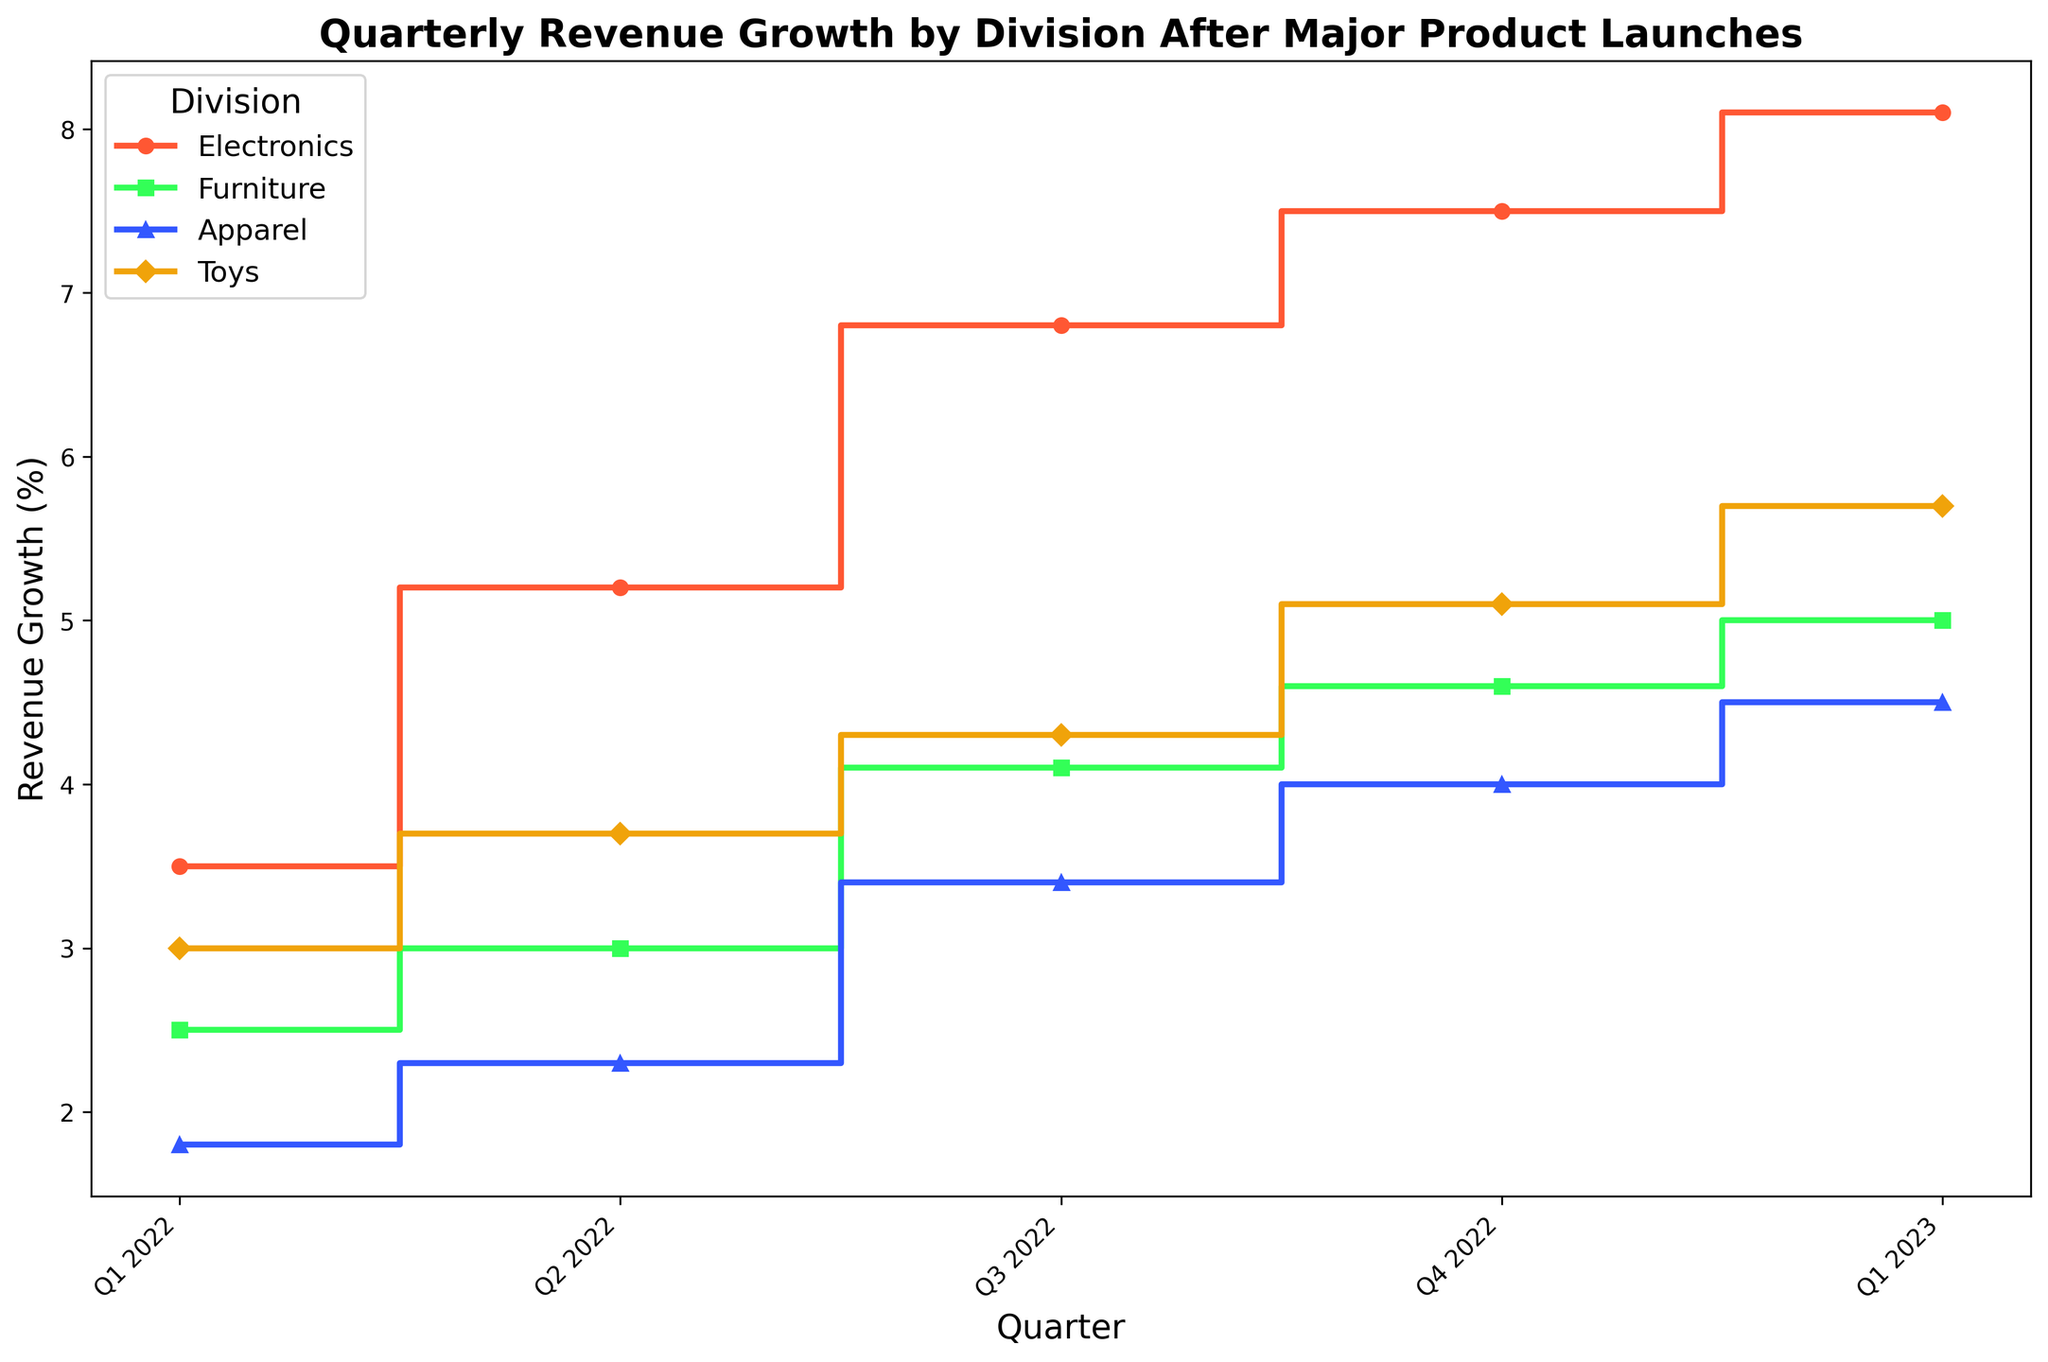Which division had the highest revenue growth in Q1 2023? Look at the revenue growth percentages for Q1 2023 across all divisions. The Electronics division had the highest growth at 8.1%.
Answer: Electronics What is the total revenue growth for the Electronics division over the five quarters shown? Sum the revenue growth percentages for the Electronics division from Q1 2022 to Q1 2023: 3.5 + 5.2 + 6.8 + 7.5 + 8.1
Answer: 31.1% Which division showed the greatest improvement in revenue growth from Q1 2022 to Q1 2023? Calculate the difference in revenue growth for each division from Q1 2022 to Q1 2023: Electronics: 8.1 - 3.5, Furniture: 5.0 - 2.5, Apparel: 4.5 - 1.8, Toys: 5.7 - 3.0. The greatest improvement is for the Electronics division with an increase of 4.6%.
Answer: Electronics By how much did the revenue growth for Apparel increase between Q3 2022 and Q4 2022? Subtract Apparel’s revenue growth in Q3 2022 from its growth in Q4 2022: 4.0 - 3.4
Answer: 0.6% Which quarters had the highest average revenue growth across all divisions? Calculate the average revenue growth for each quarter by summing the growth percentages for all divisions and dividing by the number of divisions. Q1 2022: (3.5 + 2.5 + 1.8 + 3.0) / 4, Q2 2022: (5.2 + 3.0 + 2.3 + 3.7) / 4, Q3 2022: (6.8 + 4.1 + 3.4 + 4.3) / 4, Q4 2022: (7.5 + 4.6 + 4.0 + 5.1) / 4, Q1 2023: (8.1 + 5.0 + 4.5 + 5.7) / 4. The highest average revenue growth is in Q1 2023.
Answer: Q1 2023 Which division had the smallest increase in revenue growth between Q2 2022 and Q3 2022? Subtract the revenue growth in Q2 2022 from Q3 2022 for each division: Electronics: 6.8 - 5.2, Furniture: 4.1 - 3.0, Apparel: 3.4 - 2.3, Toys: 4.3 - 3.7. The smallest increase is in the Apparel division with an increase of 1.1%.
Answer: Apparel 